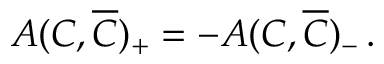Convert formula to latex. <formula><loc_0><loc_0><loc_500><loc_500>A ( C , \overline { C } ) _ { + } = - A ( C , \overline { C } ) _ { - } \, .</formula> 